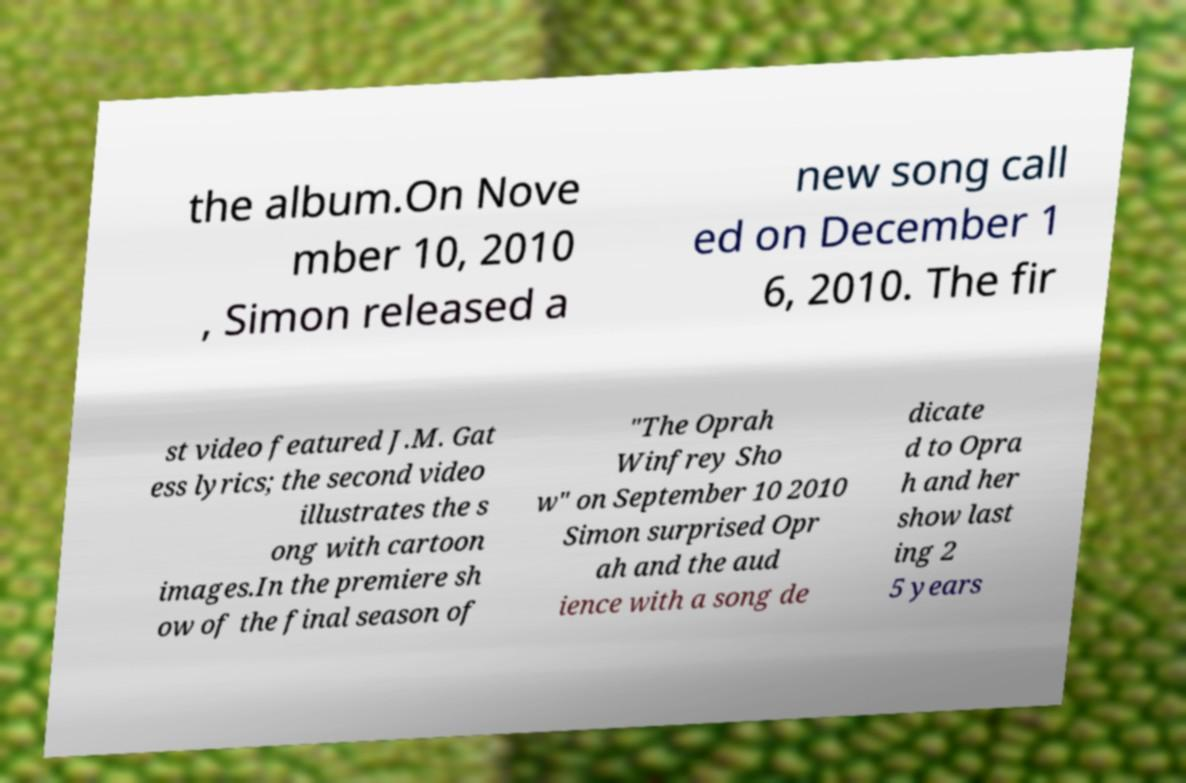Can you read and provide the text displayed in the image?This photo seems to have some interesting text. Can you extract and type it out for me? the album.On Nove mber 10, 2010 , Simon released a new song call ed on December 1 6, 2010. The fir st video featured J.M. Gat ess lyrics; the second video illustrates the s ong with cartoon images.In the premiere sh ow of the final season of "The Oprah Winfrey Sho w" on September 10 2010 Simon surprised Opr ah and the aud ience with a song de dicate d to Opra h and her show last ing 2 5 years 